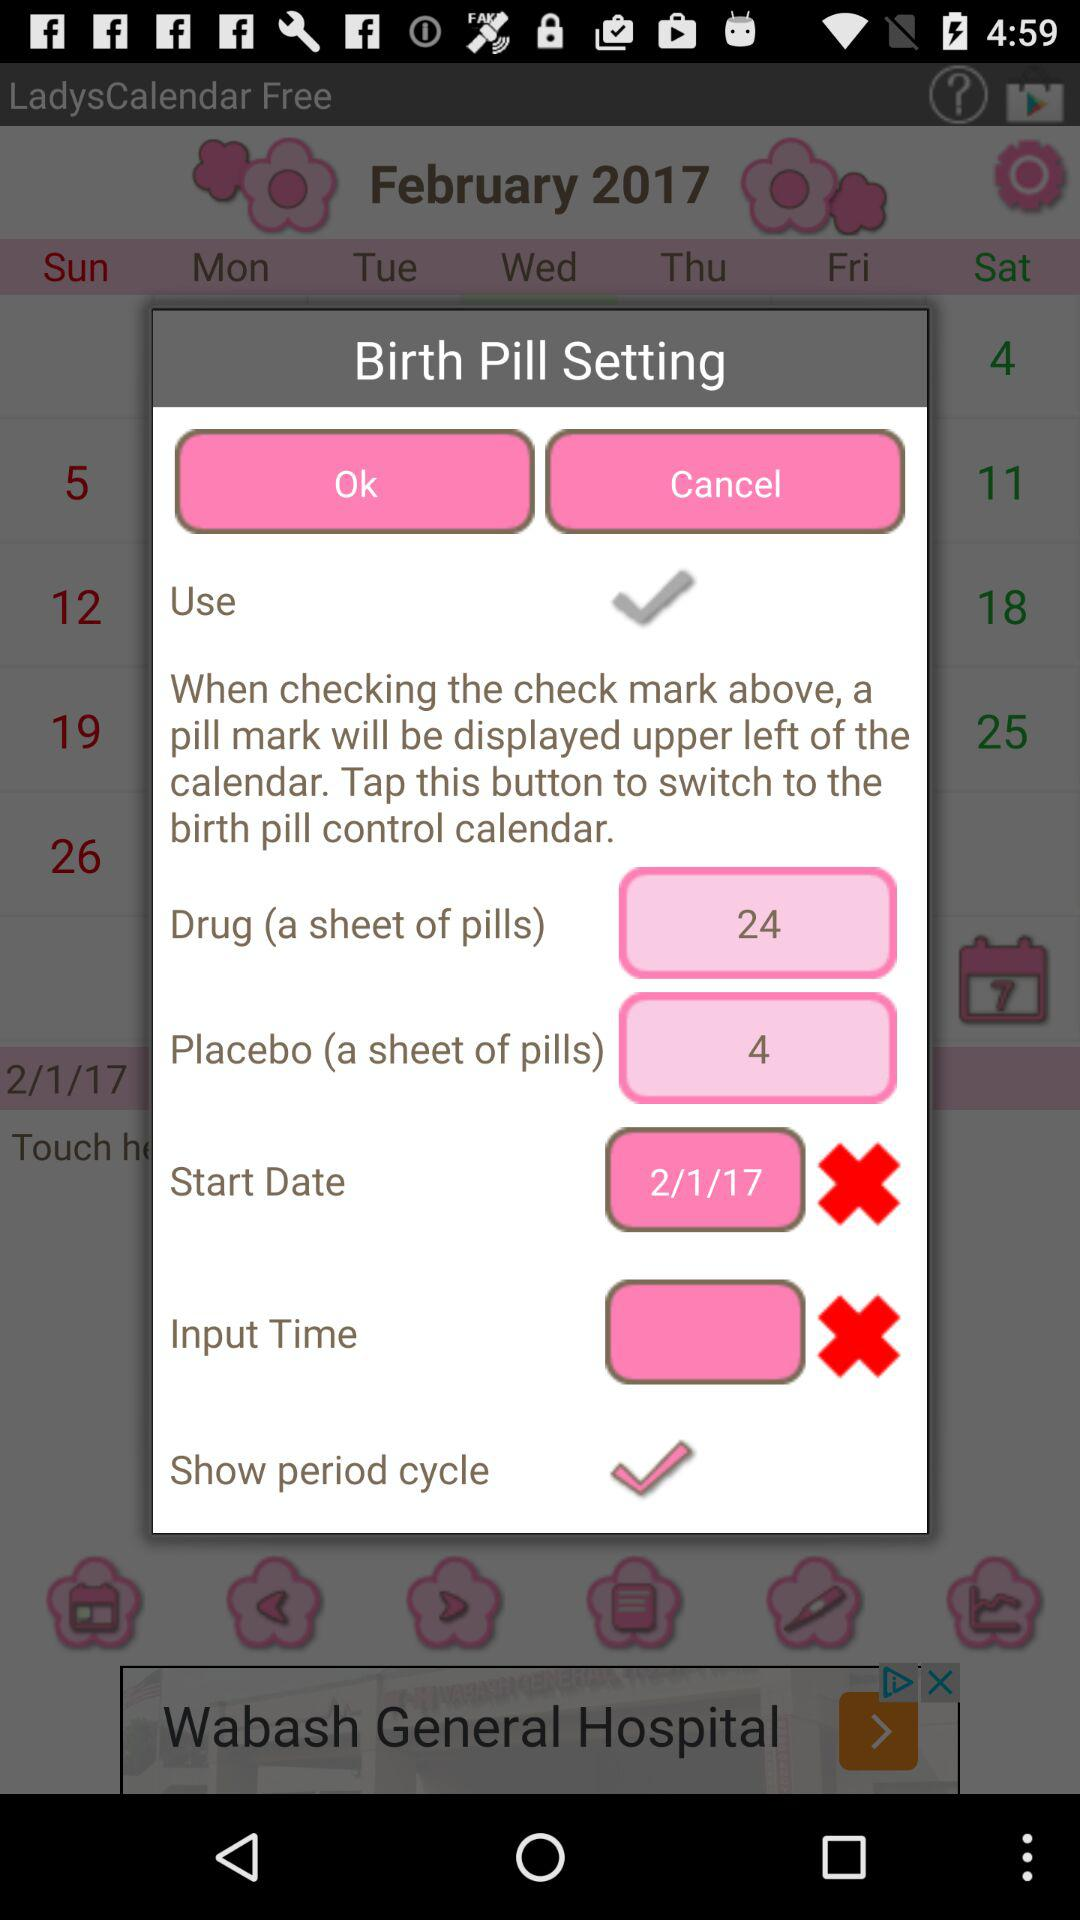How many days are in the placebo pill sheet?
Answer the question using a single word or phrase. 4 